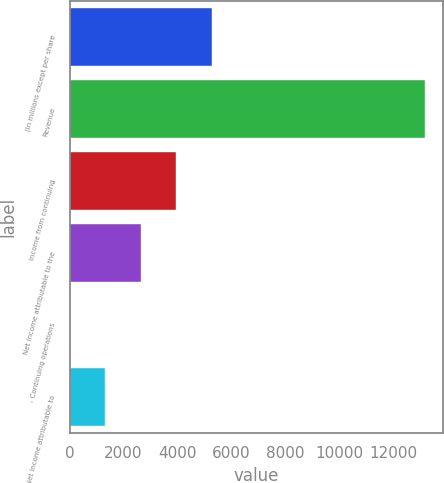Convert chart to OTSL. <chart><loc_0><loc_0><loc_500><loc_500><bar_chart><fcel>(In millions except per share<fcel>Revenue<fcel>Income from continuing<fcel>Net income attributable to the<fcel>- Continuing operations<fcel>- Net income attributable to<nl><fcel>5275.85<fcel>13185<fcel>3957.66<fcel>2639.47<fcel>3.09<fcel>1321.28<nl></chart> 